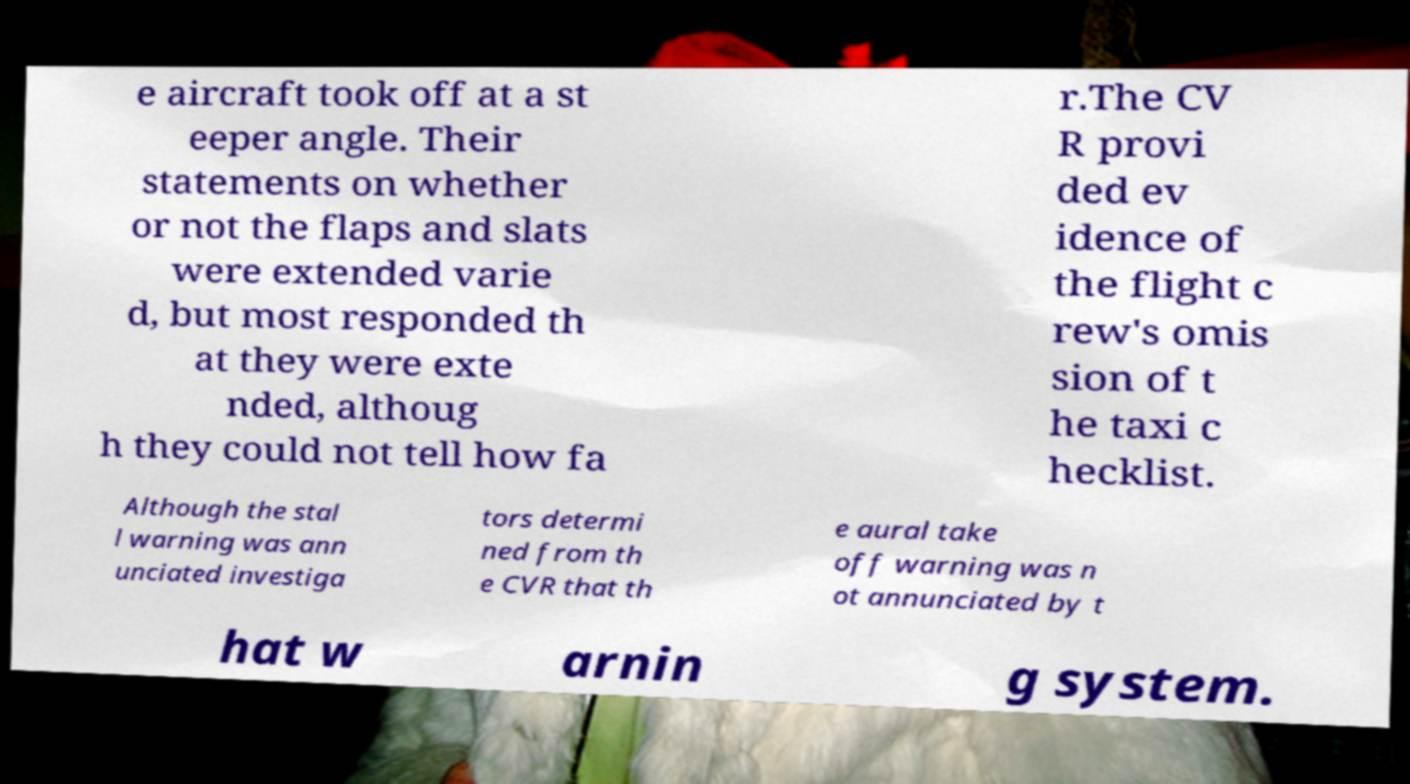Could you extract and type out the text from this image? e aircraft took off at a st eeper angle. Their statements on whether or not the flaps and slats were extended varie d, but most responded th at they were exte nded, althoug h they could not tell how fa r.The CV R provi ded ev idence of the flight c rew's omis sion of t he taxi c hecklist. Although the stal l warning was ann unciated investiga tors determi ned from th e CVR that th e aural take off warning was n ot annunciated by t hat w arnin g system. 